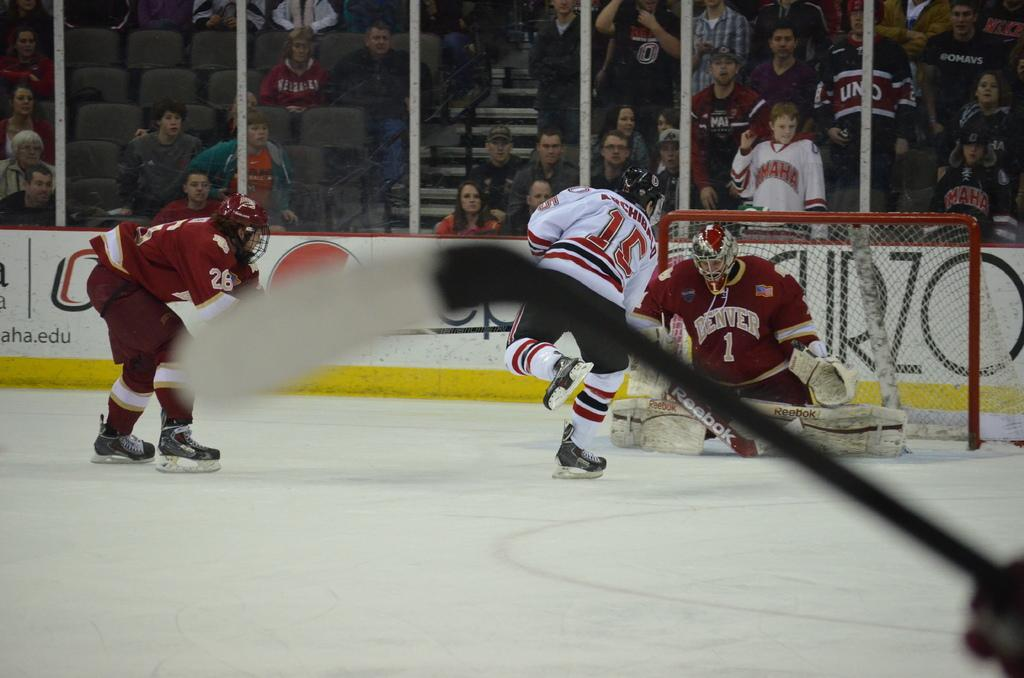<image>
Relay a brief, clear account of the picture shown. A hockey game is in progress and the goalie's jersey says Denver. 